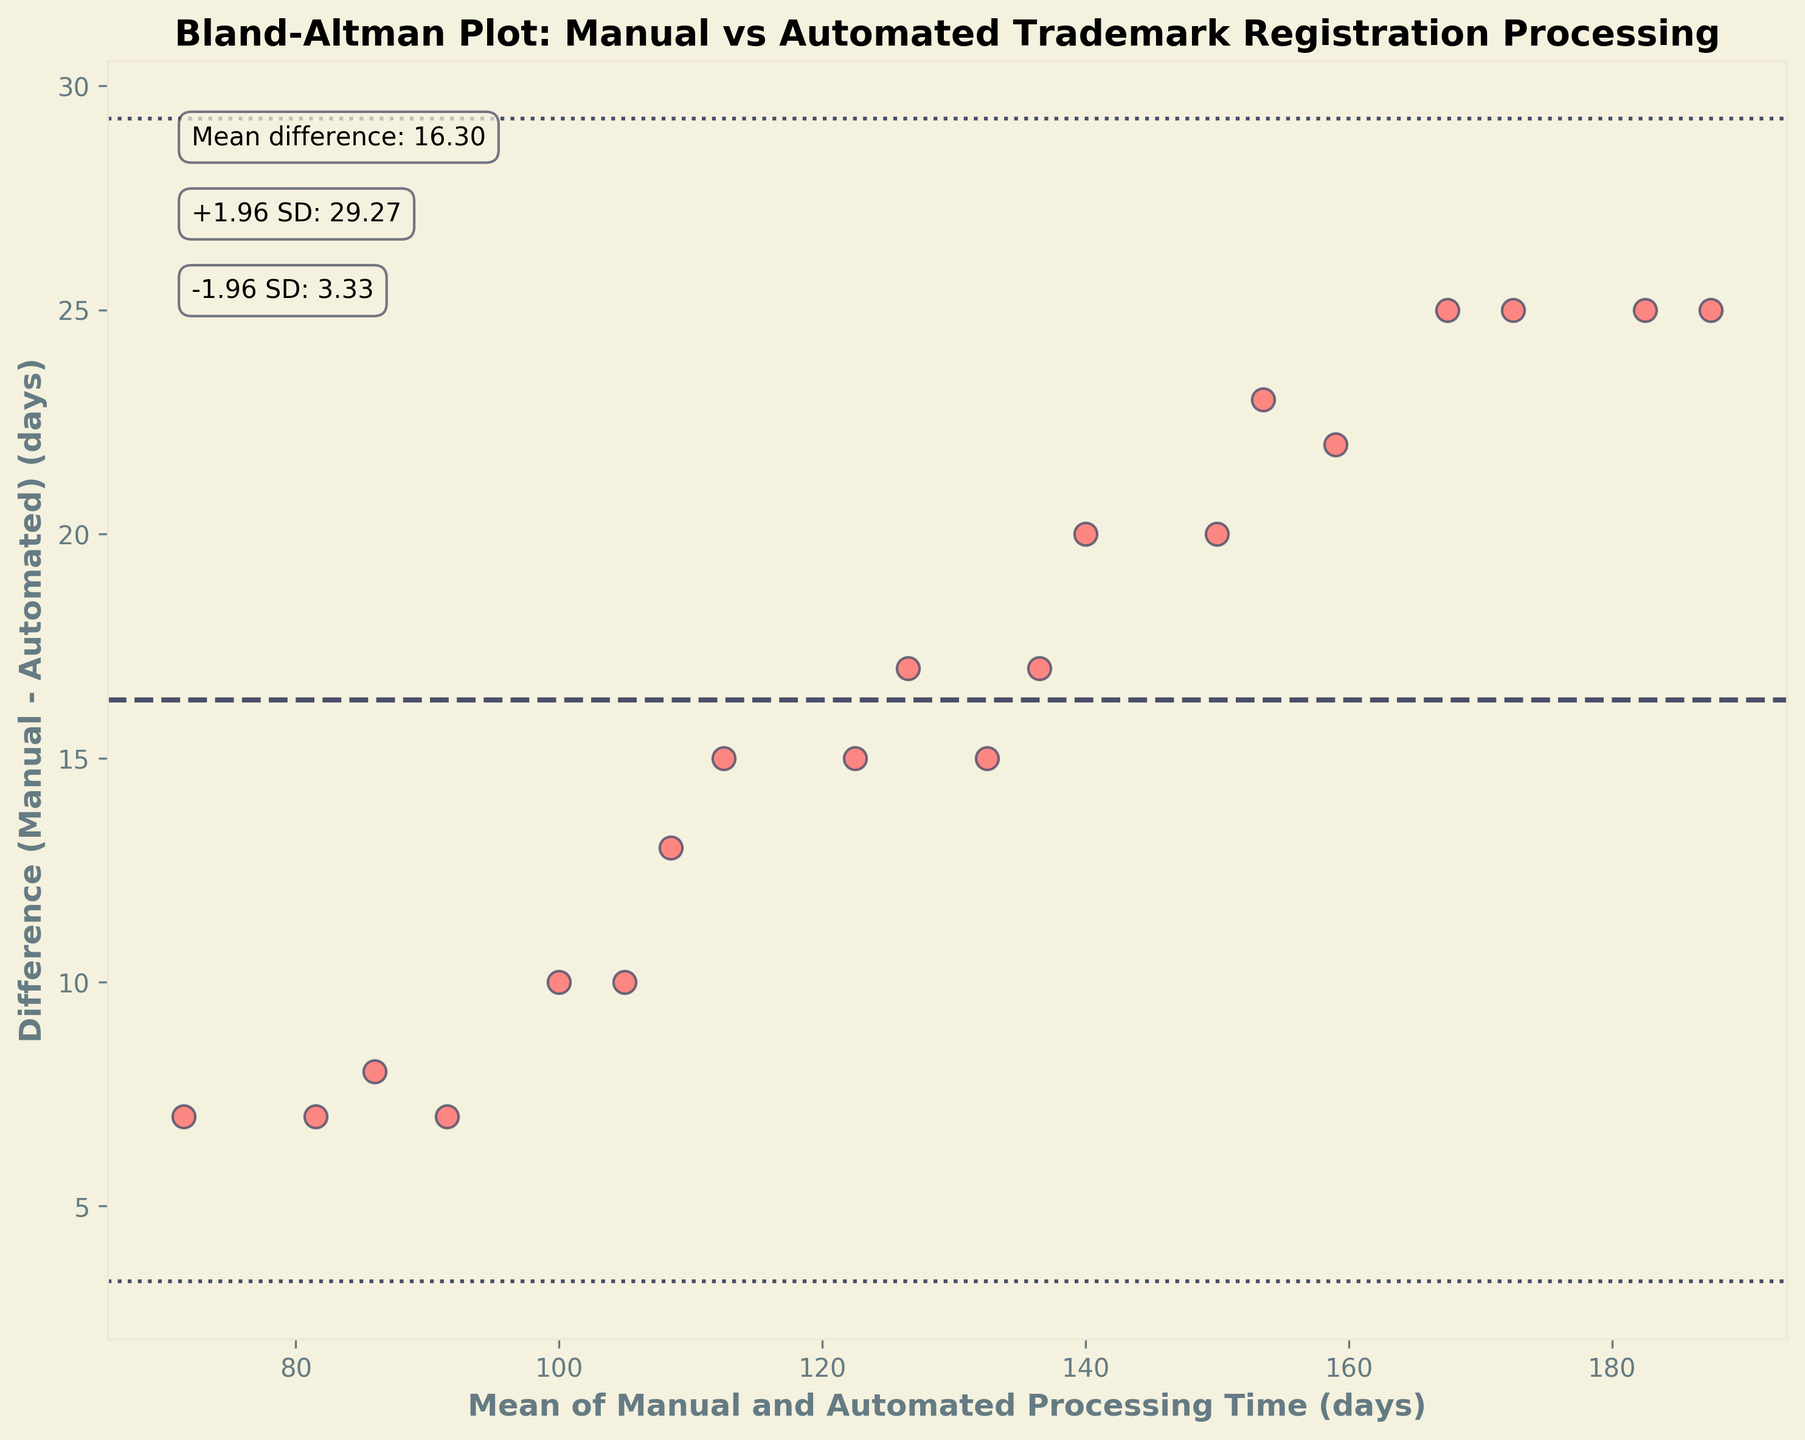What's the title of the plot? The title of the plot is clearly displayed at the top of the figure. It reads "Bland-Altman Plot: Manual vs Automated Trademark Registration Processing."
Answer: Bland-Altman Plot: Manual vs Automated Trademark Registration Processing What's the mean of the differences between manual and automated processing times? The mean of the differences is indicated by a horizontal dashed line, labeled as "Mean difference: X.XX". This label shows the mean difference clearly.
Answer: 17.20 What do the dotted lines on the plot represent? The dotted lines indicate the limits of agreement, usually at ±1.96 standard deviations from the mean difference. These limits are marked by labels.
Answer: Limits of agreement What's the mean of manual and automated processing times if the manual processing time is 120 days and the automated is 105 days? The mean of these values is \((120 + 105) / 2\). Calculate \(225 / 2\) to get the answer.
Answer: 112.5 days Which processing method generally takes less time: manual or automated? Most of the data points fall below the horizontal dashed line (mean difference), indicating that manual processing times are often higher.
Answer: Automated How many data points fall above the mean difference line? Count the number of points above the dashed line indicating the mean difference.
Answer: 7 What are the specific values of the upper and lower limits of agreement? The upper and lower limits are marked on the plot with annotations such as "+1.96 SD: X.XX" and "-1.96 SD: X.XX". Read these values.
Answer: 39.76, -5.35 What can we infer if most points cluster around the mean difference line? Clustering around the mean difference suggests that the differences between manual and automated processing times do not vary widely and are mostly consistent.
Answer: Consistent differences What's the difference between manual and automated times if the mean is 150 days and the point lies on the lower limit of agreement? Use the lower limit of agreement value (-5.35) and add it to the mean difference to estimate automated time. So, if mean = 150 and lower limit = -5.35, the manual time is approximately 150 + (-5.35/2). Automated time would be manual time - lower limit difference.
Answer: Difference close to -5.35 Do any trends or patterns stand out in the differences between manual and automated processing times? By visually inspecting the spread and clustering of the points, look for any possible trends. Patterns may suggest systematic bias or variability.
Answer: No strong trends 